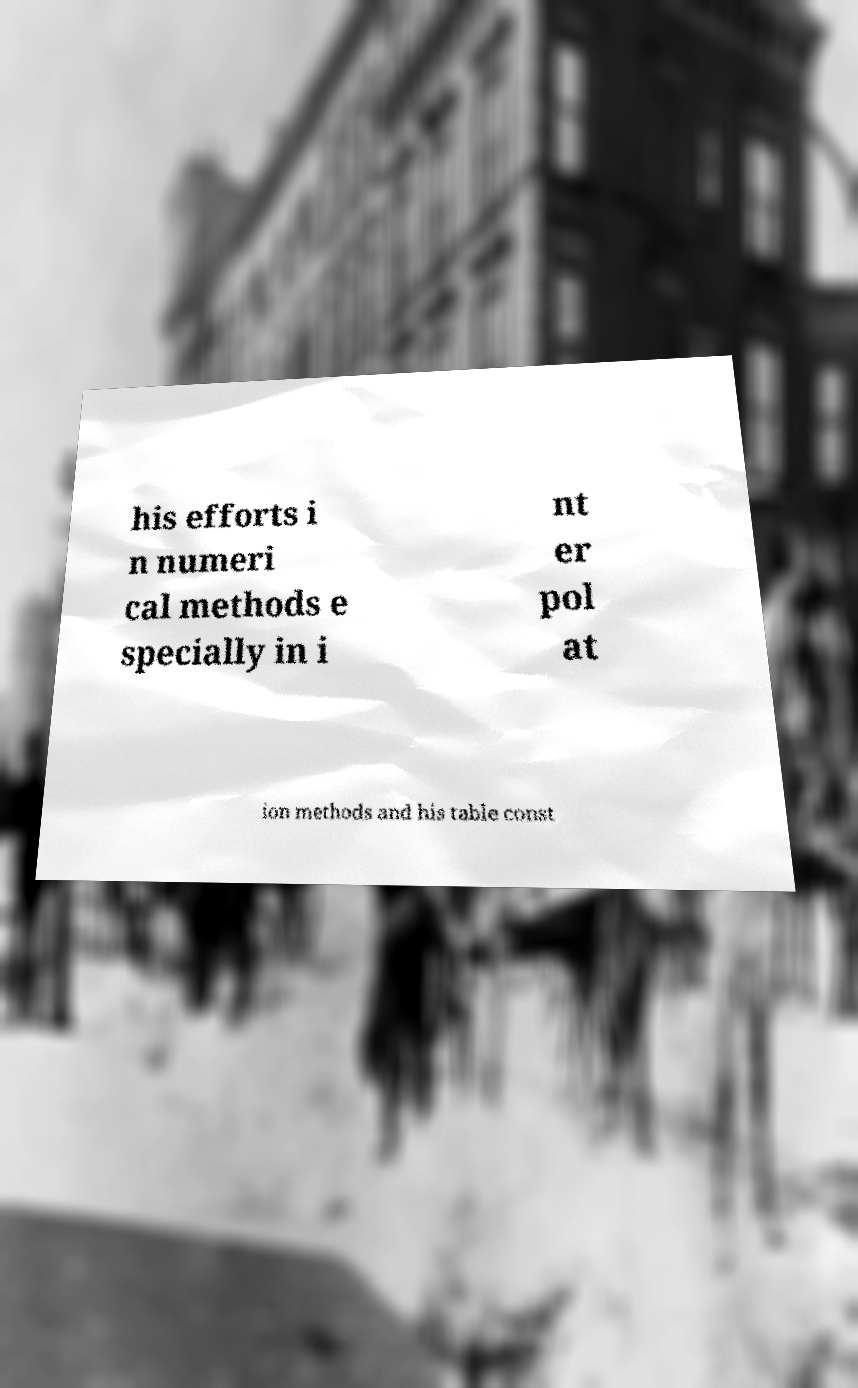Please identify and transcribe the text found in this image. his efforts i n numeri cal methods e specially in i nt er pol at ion methods and his table const 